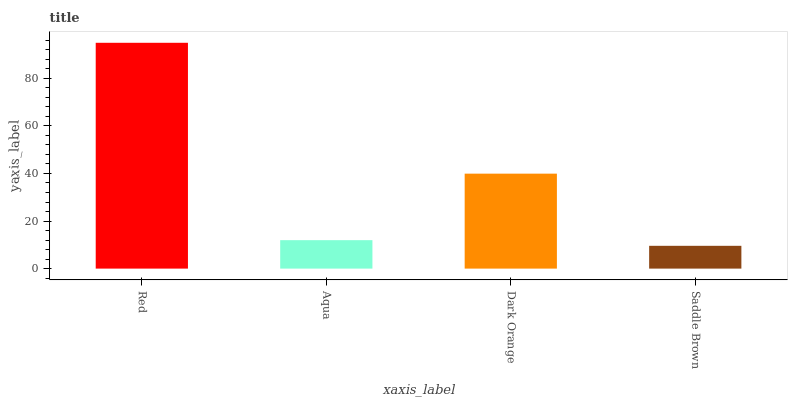Is Saddle Brown the minimum?
Answer yes or no. Yes. Is Red the maximum?
Answer yes or no. Yes. Is Aqua the minimum?
Answer yes or no. No. Is Aqua the maximum?
Answer yes or no. No. Is Red greater than Aqua?
Answer yes or no. Yes. Is Aqua less than Red?
Answer yes or no. Yes. Is Aqua greater than Red?
Answer yes or no. No. Is Red less than Aqua?
Answer yes or no. No. Is Dark Orange the high median?
Answer yes or no. Yes. Is Aqua the low median?
Answer yes or no. Yes. Is Saddle Brown the high median?
Answer yes or no. No. Is Saddle Brown the low median?
Answer yes or no. No. 